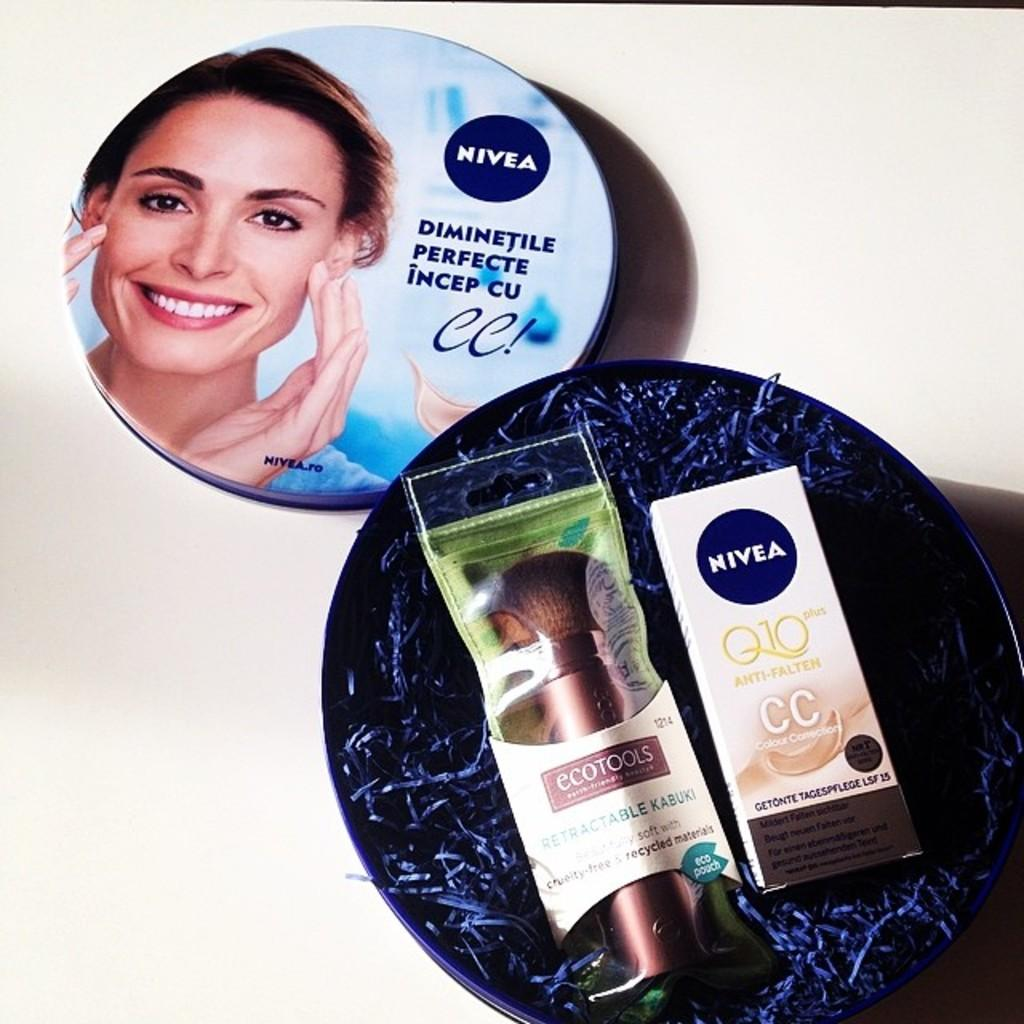<image>
Offer a succinct explanation of the picture presented. An opened round box of two Nivea products with the round lid next to the box. 